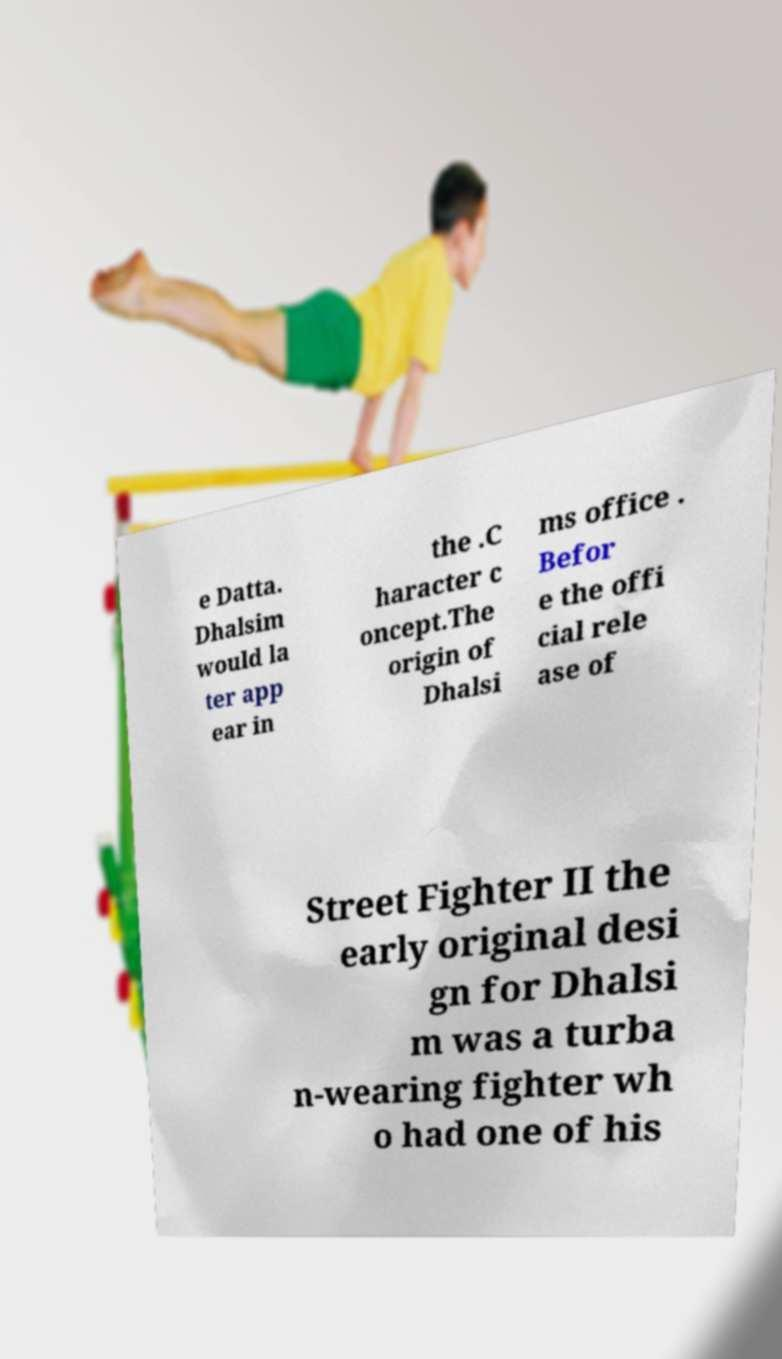What messages or text are displayed in this image? I need them in a readable, typed format. e Datta. Dhalsim would la ter app ear in the .C haracter c oncept.The origin of Dhalsi ms office . Befor e the offi cial rele ase of Street Fighter II the early original desi gn for Dhalsi m was a turba n-wearing fighter wh o had one of his 